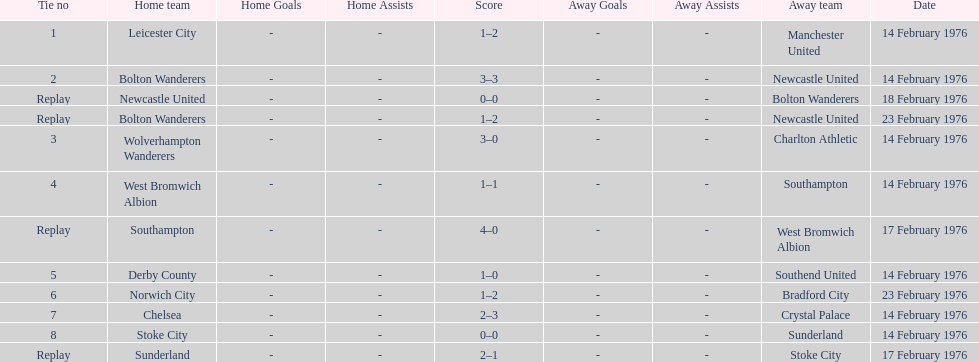How many games were replays? 4. 